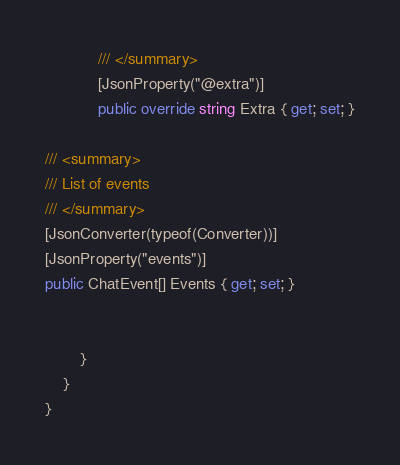Convert code to text. <code><loc_0><loc_0><loc_500><loc_500><_C#_>            /// </summary>
            [JsonProperty("@extra")]
            public override string Extra { get; set; }

/// <summary>
/// List of events
/// </summary>
[JsonConverter(typeof(Converter))]
[JsonProperty("events")]
public ChatEvent[] Events { get; set; }


        }
    }
}
</code> 